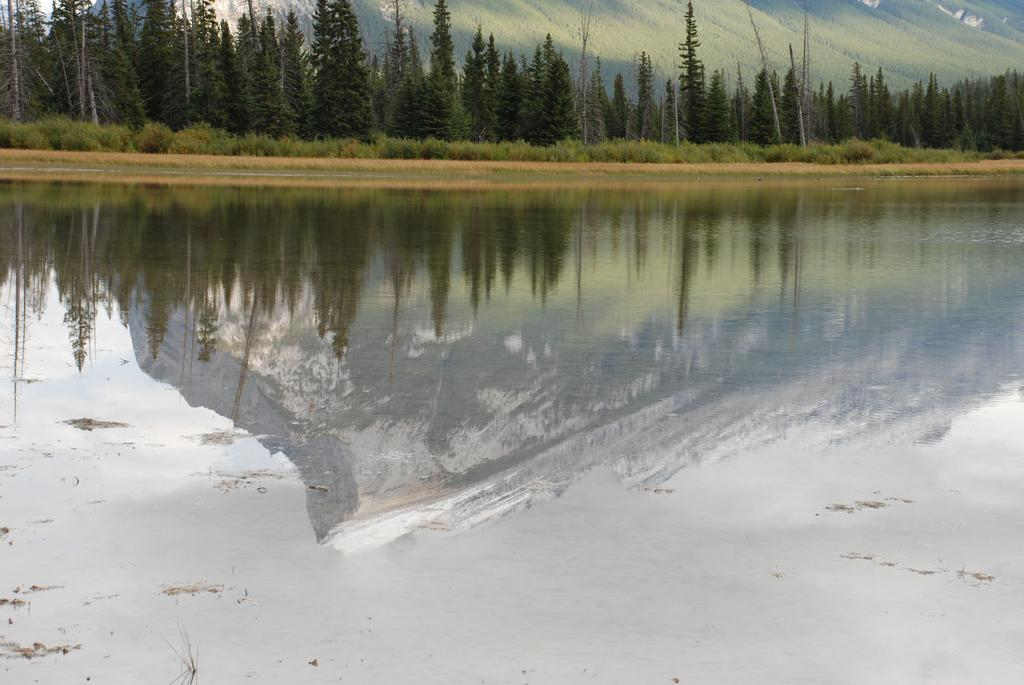What is the primary element in the image? There is a water surface in the image. What is reflected on the water surface? The image of a mountain is reflected on the water surface. What type of vegetation can be seen in the background of the image? There are many trees in the background of the image. How many oranges are floating on the water surface in the image? There are no oranges present in the image; it features a water surface with a reflected mountain image and trees in the background. 